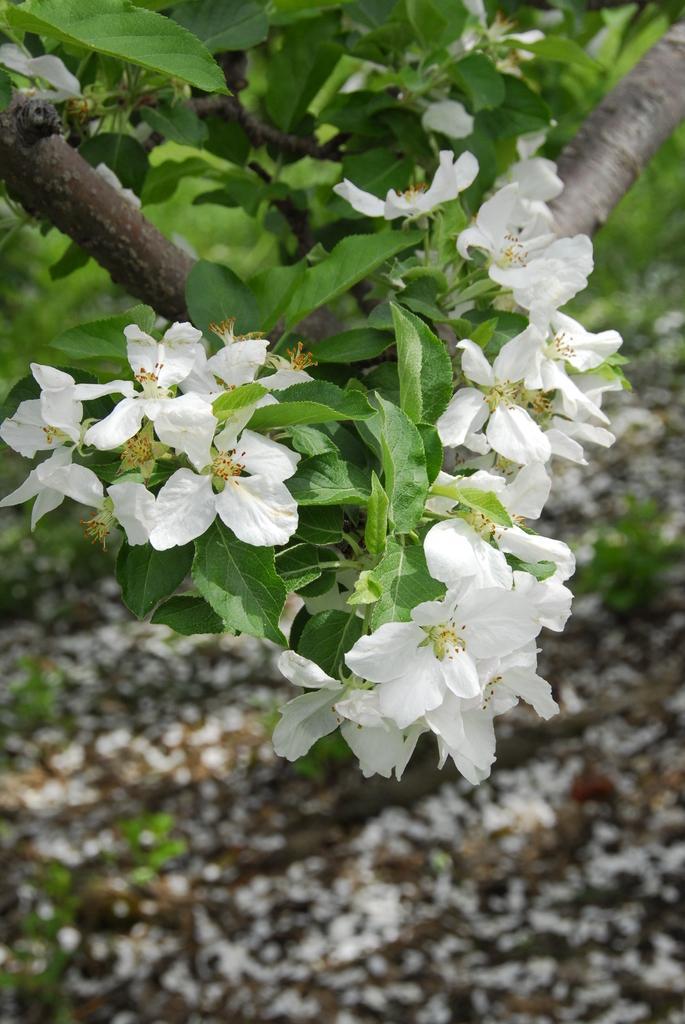In one or two sentences, can you explain what this image depicts? In the foreground of this image, there are white flowers to the plant. On the bottom, there are flowers on the ground. 